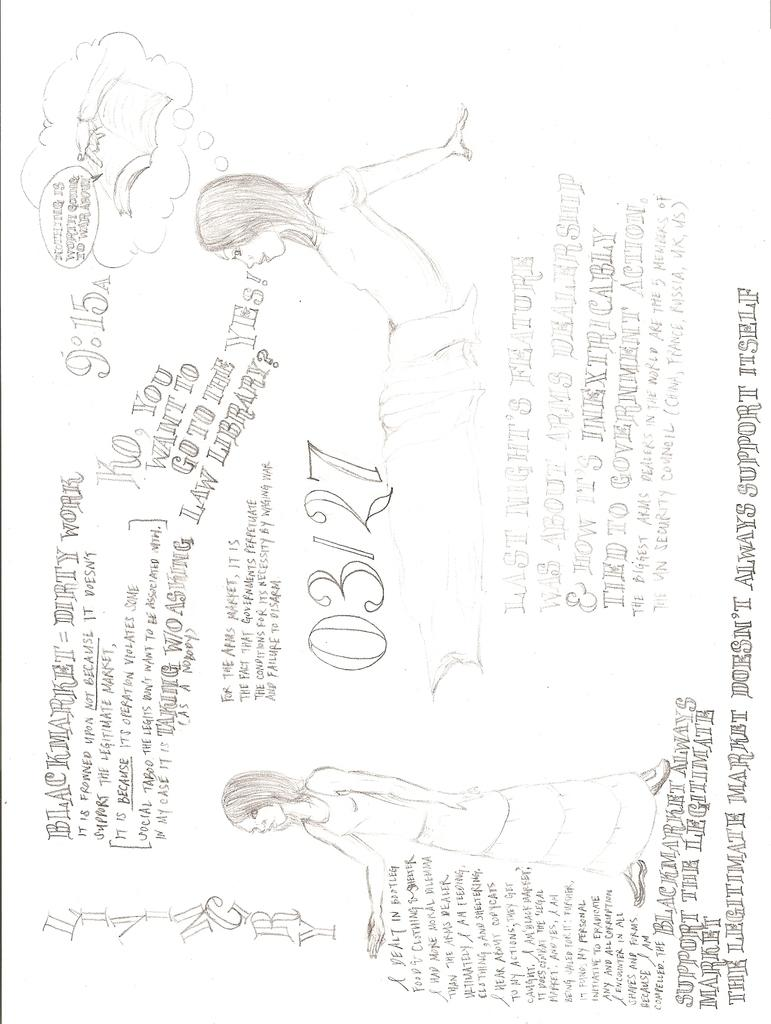What is the main subject of the image? There is an art piece in the image. What is the color of the background in the art piece? The art piece has a white colored background. What can be found within the art piece besides the background? There is writing and a drawing of two persons in the art piece. What type of jellyfish is depicted in the art piece? There is no jellyfish present in the art piece; it contains a drawing of two persons. What is the name of the person on the left side of the art piece? The image does not provide any names for the persons depicted in the art piece. 